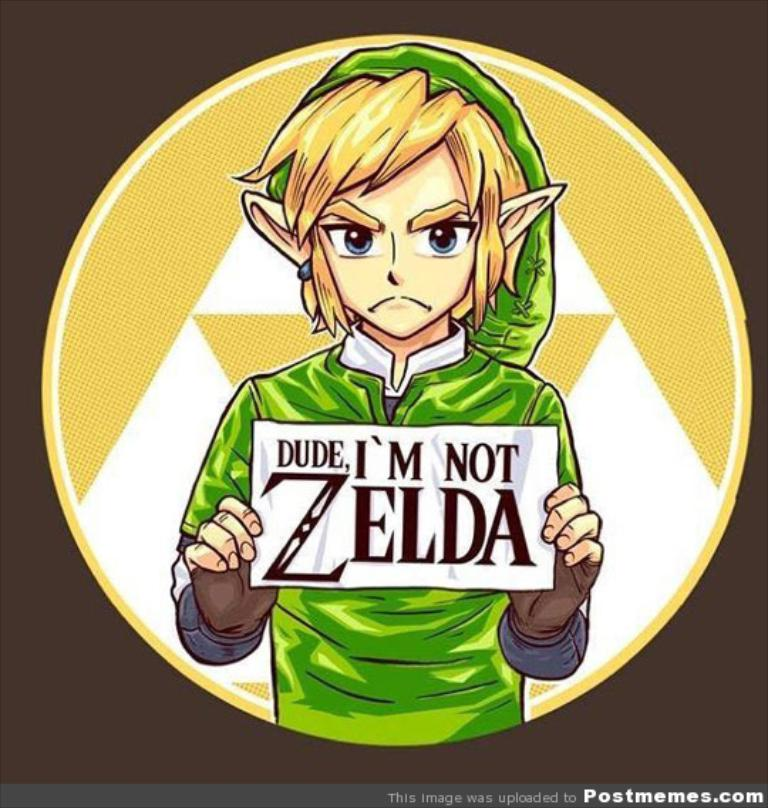Can you explain why Link is often confused with Zelda? The confusion often arises because the video game series is titled 'The Legend of Zelda,' leading many to mistakenly believe Zelda is the protagonist. However, Zelda is the princess whom Link, the actual protagonist, often needs to save. This mix-up is popular even among those less familiar with the game series, contributing to its mention in various media and fan discussions. 